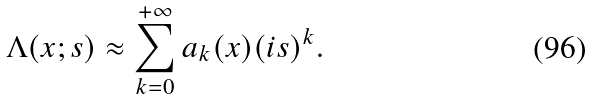Convert formula to latex. <formula><loc_0><loc_0><loc_500><loc_500>\Lambda ( x ; s ) \approx \sum _ { k = 0 } ^ { + \infty } a _ { k } ( x ) ( i s ) ^ { k } .</formula> 